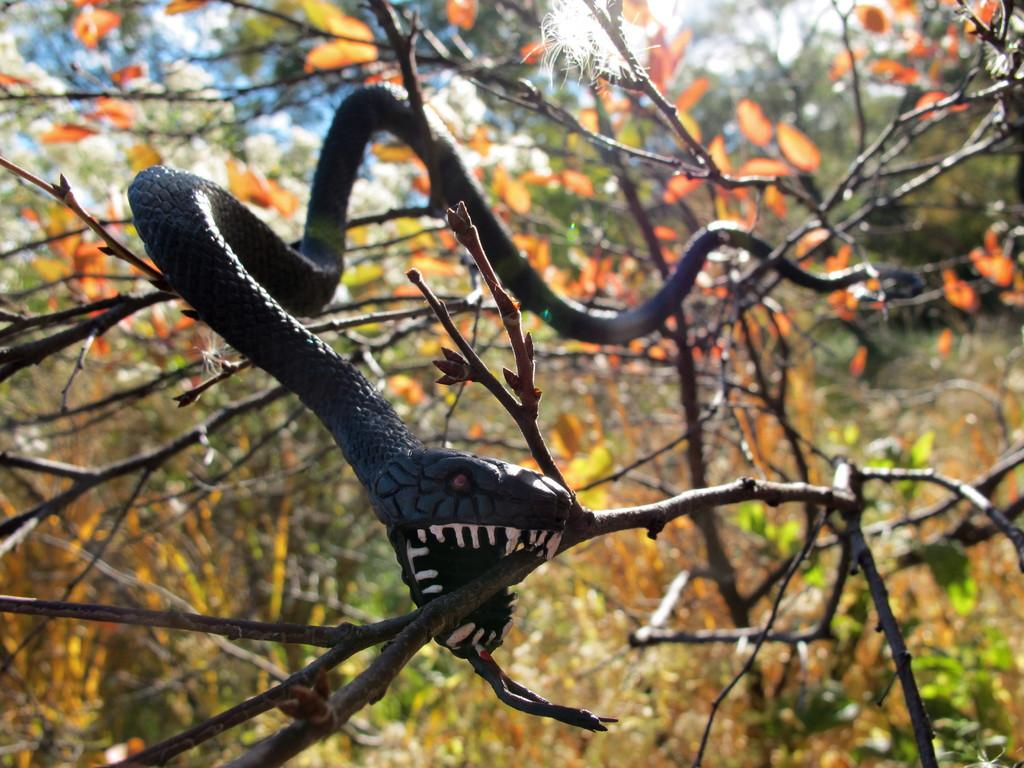What animal is present in the image? There is a snake in the image. Where is the snake located? The snake is on a tree. What can be seen on the tree besides the snake? There are leaves on the tree. What is visible at the top of the image? The sky is visible at the top of the image. Can you describe the snake in the image? The snake appears to be a toy. How many mice are hiding under the sheet in the image? There are no mice or sheets present in the image. What verse can be recited while observing the snake in the image? There is no verse associated with the snake in the image. 